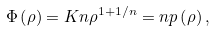<formula> <loc_0><loc_0><loc_500><loc_500>\Phi \left ( \rho \right ) = K n \rho ^ { 1 + 1 / n } = n p \left ( \rho \right ) ,</formula> 